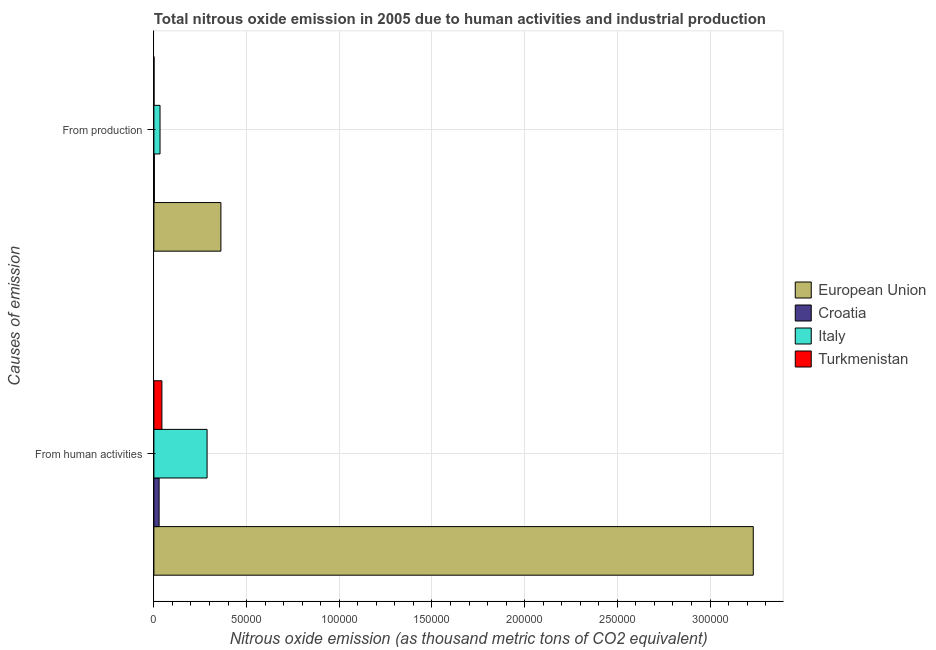How many groups of bars are there?
Provide a succinct answer. 2. Are the number of bars on each tick of the Y-axis equal?
Provide a succinct answer. Yes. How many bars are there on the 1st tick from the bottom?
Provide a short and direct response. 4. What is the label of the 1st group of bars from the top?
Provide a succinct answer. From production. What is the amount of emissions from human activities in European Union?
Provide a succinct answer. 3.23e+05. Across all countries, what is the maximum amount of emissions generated from industries?
Your answer should be compact. 3.62e+04. Across all countries, what is the minimum amount of emissions from human activities?
Make the answer very short. 2823.4. In which country was the amount of emissions generated from industries maximum?
Make the answer very short. European Union. In which country was the amount of emissions generated from industries minimum?
Make the answer very short. Turkmenistan. What is the total amount of emissions generated from industries in the graph?
Keep it short and to the point. 3.98e+04. What is the difference between the amount of emissions from human activities in Croatia and that in European Union?
Offer a very short reply. -3.21e+05. What is the difference between the amount of emissions generated from industries in Italy and the amount of emissions from human activities in European Union?
Offer a very short reply. -3.20e+05. What is the average amount of emissions from human activities per country?
Keep it short and to the point. 8.98e+04. What is the difference between the amount of emissions generated from industries and amount of emissions from human activities in Croatia?
Make the answer very short. -2583.1. In how many countries, is the amount of emissions from human activities greater than 10000 thousand metric tons?
Provide a short and direct response. 2. What is the ratio of the amount of emissions from human activities in Croatia to that in European Union?
Give a very brief answer. 0.01. What does the 1st bar from the top in From production represents?
Ensure brevity in your answer.  Turkmenistan. What does the 2nd bar from the bottom in From production represents?
Provide a succinct answer. Croatia. How many bars are there?
Your response must be concise. 8. Are all the bars in the graph horizontal?
Offer a very short reply. Yes. How many countries are there in the graph?
Make the answer very short. 4. Are the values on the major ticks of X-axis written in scientific E-notation?
Ensure brevity in your answer.  No. Does the graph contain any zero values?
Offer a terse response. No. Where does the legend appear in the graph?
Give a very brief answer. Center right. How are the legend labels stacked?
Your answer should be compact. Vertical. What is the title of the graph?
Your answer should be very brief. Total nitrous oxide emission in 2005 due to human activities and industrial production. Does "Switzerland" appear as one of the legend labels in the graph?
Provide a succinct answer. No. What is the label or title of the X-axis?
Make the answer very short. Nitrous oxide emission (as thousand metric tons of CO2 equivalent). What is the label or title of the Y-axis?
Your answer should be compact. Causes of emission. What is the Nitrous oxide emission (as thousand metric tons of CO2 equivalent) in European Union in From human activities?
Offer a very short reply. 3.23e+05. What is the Nitrous oxide emission (as thousand metric tons of CO2 equivalent) of Croatia in From human activities?
Make the answer very short. 2823.4. What is the Nitrous oxide emission (as thousand metric tons of CO2 equivalent) in Italy in From human activities?
Make the answer very short. 2.87e+04. What is the Nitrous oxide emission (as thousand metric tons of CO2 equivalent) of Turkmenistan in From human activities?
Give a very brief answer. 4330.6. What is the Nitrous oxide emission (as thousand metric tons of CO2 equivalent) in European Union in From production?
Ensure brevity in your answer.  3.62e+04. What is the Nitrous oxide emission (as thousand metric tons of CO2 equivalent) of Croatia in From production?
Your answer should be compact. 240.3. What is the Nitrous oxide emission (as thousand metric tons of CO2 equivalent) of Italy in From production?
Offer a terse response. 3320.3. What is the Nitrous oxide emission (as thousand metric tons of CO2 equivalent) of Turkmenistan in From production?
Your response must be concise. 76.5. Across all Causes of emission, what is the maximum Nitrous oxide emission (as thousand metric tons of CO2 equivalent) in European Union?
Your answer should be very brief. 3.23e+05. Across all Causes of emission, what is the maximum Nitrous oxide emission (as thousand metric tons of CO2 equivalent) in Croatia?
Provide a succinct answer. 2823.4. Across all Causes of emission, what is the maximum Nitrous oxide emission (as thousand metric tons of CO2 equivalent) in Italy?
Ensure brevity in your answer.  2.87e+04. Across all Causes of emission, what is the maximum Nitrous oxide emission (as thousand metric tons of CO2 equivalent) of Turkmenistan?
Provide a succinct answer. 4330.6. Across all Causes of emission, what is the minimum Nitrous oxide emission (as thousand metric tons of CO2 equivalent) in European Union?
Your answer should be compact. 3.62e+04. Across all Causes of emission, what is the minimum Nitrous oxide emission (as thousand metric tons of CO2 equivalent) in Croatia?
Your answer should be compact. 240.3. Across all Causes of emission, what is the minimum Nitrous oxide emission (as thousand metric tons of CO2 equivalent) in Italy?
Your answer should be compact. 3320.3. Across all Causes of emission, what is the minimum Nitrous oxide emission (as thousand metric tons of CO2 equivalent) of Turkmenistan?
Offer a very short reply. 76.5. What is the total Nitrous oxide emission (as thousand metric tons of CO2 equivalent) of European Union in the graph?
Offer a terse response. 3.59e+05. What is the total Nitrous oxide emission (as thousand metric tons of CO2 equivalent) in Croatia in the graph?
Provide a short and direct response. 3063.7. What is the total Nitrous oxide emission (as thousand metric tons of CO2 equivalent) of Italy in the graph?
Offer a terse response. 3.20e+04. What is the total Nitrous oxide emission (as thousand metric tons of CO2 equivalent) in Turkmenistan in the graph?
Your response must be concise. 4407.1. What is the difference between the Nitrous oxide emission (as thousand metric tons of CO2 equivalent) in European Union in From human activities and that in From production?
Offer a very short reply. 2.87e+05. What is the difference between the Nitrous oxide emission (as thousand metric tons of CO2 equivalent) in Croatia in From human activities and that in From production?
Offer a terse response. 2583.1. What is the difference between the Nitrous oxide emission (as thousand metric tons of CO2 equivalent) in Italy in From human activities and that in From production?
Your answer should be compact. 2.54e+04. What is the difference between the Nitrous oxide emission (as thousand metric tons of CO2 equivalent) in Turkmenistan in From human activities and that in From production?
Offer a terse response. 4254.1. What is the difference between the Nitrous oxide emission (as thousand metric tons of CO2 equivalent) of European Union in From human activities and the Nitrous oxide emission (as thousand metric tons of CO2 equivalent) of Croatia in From production?
Your answer should be very brief. 3.23e+05. What is the difference between the Nitrous oxide emission (as thousand metric tons of CO2 equivalent) in European Union in From human activities and the Nitrous oxide emission (as thousand metric tons of CO2 equivalent) in Italy in From production?
Offer a very short reply. 3.20e+05. What is the difference between the Nitrous oxide emission (as thousand metric tons of CO2 equivalent) of European Union in From human activities and the Nitrous oxide emission (as thousand metric tons of CO2 equivalent) of Turkmenistan in From production?
Ensure brevity in your answer.  3.23e+05. What is the difference between the Nitrous oxide emission (as thousand metric tons of CO2 equivalent) of Croatia in From human activities and the Nitrous oxide emission (as thousand metric tons of CO2 equivalent) of Italy in From production?
Keep it short and to the point. -496.9. What is the difference between the Nitrous oxide emission (as thousand metric tons of CO2 equivalent) in Croatia in From human activities and the Nitrous oxide emission (as thousand metric tons of CO2 equivalent) in Turkmenistan in From production?
Provide a succinct answer. 2746.9. What is the difference between the Nitrous oxide emission (as thousand metric tons of CO2 equivalent) in Italy in From human activities and the Nitrous oxide emission (as thousand metric tons of CO2 equivalent) in Turkmenistan in From production?
Offer a terse response. 2.86e+04. What is the average Nitrous oxide emission (as thousand metric tons of CO2 equivalent) of European Union per Causes of emission?
Give a very brief answer. 1.80e+05. What is the average Nitrous oxide emission (as thousand metric tons of CO2 equivalent) of Croatia per Causes of emission?
Give a very brief answer. 1531.85. What is the average Nitrous oxide emission (as thousand metric tons of CO2 equivalent) in Italy per Causes of emission?
Offer a terse response. 1.60e+04. What is the average Nitrous oxide emission (as thousand metric tons of CO2 equivalent) of Turkmenistan per Causes of emission?
Provide a succinct answer. 2203.55. What is the difference between the Nitrous oxide emission (as thousand metric tons of CO2 equivalent) of European Union and Nitrous oxide emission (as thousand metric tons of CO2 equivalent) of Croatia in From human activities?
Your response must be concise. 3.21e+05. What is the difference between the Nitrous oxide emission (as thousand metric tons of CO2 equivalent) of European Union and Nitrous oxide emission (as thousand metric tons of CO2 equivalent) of Italy in From human activities?
Keep it short and to the point. 2.95e+05. What is the difference between the Nitrous oxide emission (as thousand metric tons of CO2 equivalent) in European Union and Nitrous oxide emission (as thousand metric tons of CO2 equivalent) in Turkmenistan in From human activities?
Provide a short and direct response. 3.19e+05. What is the difference between the Nitrous oxide emission (as thousand metric tons of CO2 equivalent) in Croatia and Nitrous oxide emission (as thousand metric tons of CO2 equivalent) in Italy in From human activities?
Offer a terse response. -2.59e+04. What is the difference between the Nitrous oxide emission (as thousand metric tons of CO2 equivalent) in Croatia and Nitrous oxide emission (as thousand metric tons of CO2 equivalent) in Turkmenistan in From human activities?
Your answer should be very brief. -1507.2. What is the difference between the Nitrous oxide emission (as thousand metric tons of CO2 equivalent) in Italy and Nitrous oxide emission (as thousand metric tons of CO2 equivalent) in Turkmenistan in From human activities?
Provide a succinct answer. 2.44e+04. What is the difference between the Nitrous oxide emission (as thousand metric tons of CO2 equivalent) in European Union and Nitrous oxide emission (as thousand metric tons of CO2 equivalent) in Croatia in From production?
Your response must be concise. 3.59e+04. What is the difference between the Nitrous oxide emission (as thousand metric tons of CO2 equivalent) in European Union and Nitrous oxide emission (as thousand metric tons of CO2 equivalent) in Italy in From production?
Your response must be concise. 3.28e+04. What is the difference between the Nitrous oxide emission (as thousand metric tons of CO2 equivalent) in European Union and Nitrous oxide emission (as thousand metric tons of CO2 equivalent) in Turkmenistan in From production?
Provide a succinct answer. 3.61e+04. What is the difference between the Nitrous oxide emission (as thousand metric tons of CO2 equivalent) of Croatia and Nitrous oxide emission (as thousand metric tons of CO2 equivalent) of Italy in From production?
Ensure brevity in your answer.  -3080. What is the difference between the Nitrous oxide emission (as thousand metric tons of CO2 equivalent) in Croatia and Nitrous oxide emission (as thousand metric tons of CO2 equivalent) in Turkmenistan in From production?
Keep it short and to the point. 163.8. What is the difference between the Nitrous oxide emission (as thousand metric tons of CO2 equivalent) in Italy and Nitrous oxide emission (as thousand metric tons of CO2 equivalent) in Turkmenistan in From production?
Ensure brevity in your answer.  3243.8. What is the ratio of the Nitrous oxide emission (as thousand metric tons of CO2 equivalent) in European Union in From human activities to that in From production?
Offer a terse response. 8.94. What is the ratio of the Nitrous oxide emission (as thousand metric tons of CO2 equivalent) in Croatia in From human activities to that in From production?
Your answer should be compact. 11.75. What is the ratio of the Nitrous oxide emission (as thousand metric tons of CO2 equivalent) in Italy in From human activities to that in From production?
Your answer should be compact. 8.64. What is the ratio of the Nitrous oxide emission (as thousand metric tons of CO2 equivalent) in Turkmenistan in From human activities to that in From production?
Your answer should be very brief. 56.61. What is the difference between the highest and the second highest Nitrous oxide emission (as thousand metric tons of CO2 equivalent) in European Union?
Keep it short and to the point. 2.87e+05. What is the difference between the highest and the second highest Nitrous oxide emission (as thousand metric tons of CO2 equivalent) of Croatia?
Keep it short and to the point. 2583.1. What is the difference between the highest and the second highest Nitrous oxide emission (as thousand metric tons of CO2 equivalent) of Italy?
Your answer should be very brief. 2.54e+04. What is the difference between the highest and the second highest Nitrous oxide emission (as thousand metric tons of CO2 equivalent) of Turkmenistan?
Your answer should be compact. 4254.1. What is the difference between the highest and the lowest Nitrous oxide emission (as thousand metric tons of CO2 equivalent) of European Union?
Provide a succinct answer. 2.87e+05. What is the difference between the highest and the lowest Nitrous oxide emission (as thousand metric tons of CO2 equivalent) in Croatia?
Your answer should be very brief. 2583.1. What is the difference between the highest and the lowest Nitrous oxide emission (as thousand metric tons of CO2 equivalent) of Italy?
Give a very brief answer. 2.54e+04. What is the difference between the highest and the lowest Nitrous oxide emission (as thousand metric tons of CO2 equivalent) of Turkmenistan?
Make the answer very short. 4254.1. 